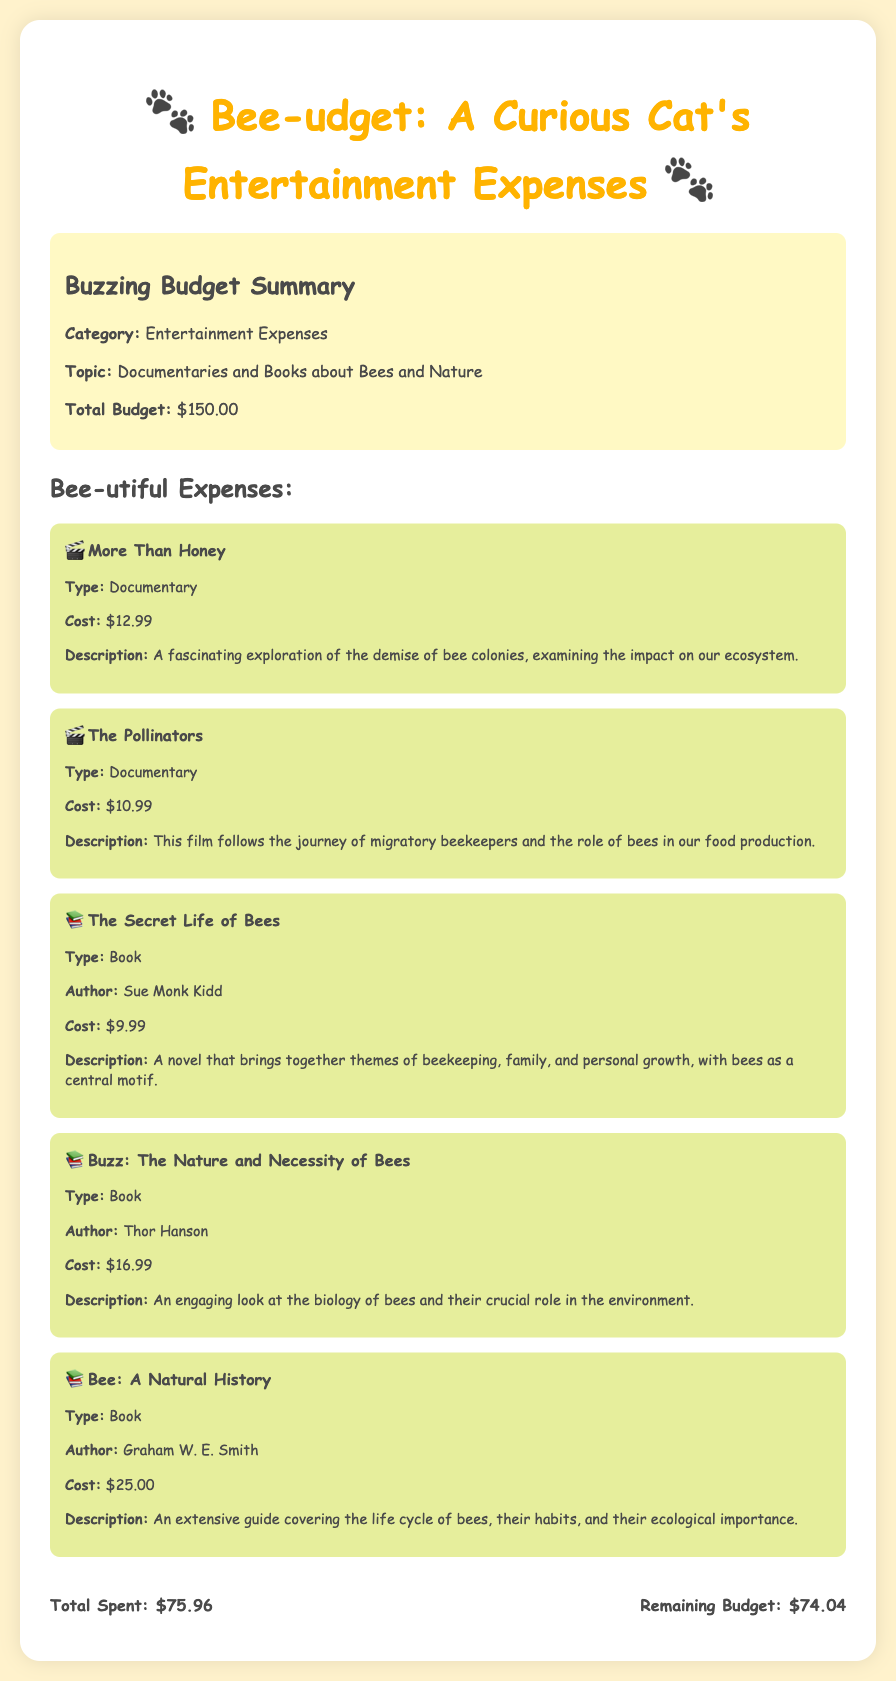What is the total budget? The total budget amount listed in the document is $150.00.
Answer: $150.00 How much was spent on "The Pollinators"? The cost of "The Pollinators" documentary is explicitly mentioned as $10.99.
Answer: $10.99 Who is the author of "The Secret Life of Bees"? The document specifies that the author of "The Secret Life of Bees" is Sue Monk Kidd.
Answer: Sue Monk Kidd What is the cost of "Bee: A Natural History"? The document states that "Bee: A Natural History" costs $25.00.
Answer: $25.00 What is the total amount spent on the expenses? The total amount spent is summarized as $75.96 in the document.
Answer: $75.96 How much is left in the budget after expenses? The remaining budget, after deducting expenses, is stated as $74.04.
Answer: $74.04 How many documentaries are listed in the expenses? The document lists a total of 2 documentaries: "More Than Honey" and "The Pollinators."
Answer: 2 What type of items are included in the budget? The budget includes expenses related to documentaries and books about bees and nature.
Answer: Documentaries and Books What is the description of "Buzz: The Nature and Necessity of Bees"? The description provided in the document highlights that it offers an engaging look at the biology of bees and their crucial role in the environment.
Answer: An engaging look at the biology of bees and their crucial role in the environment 